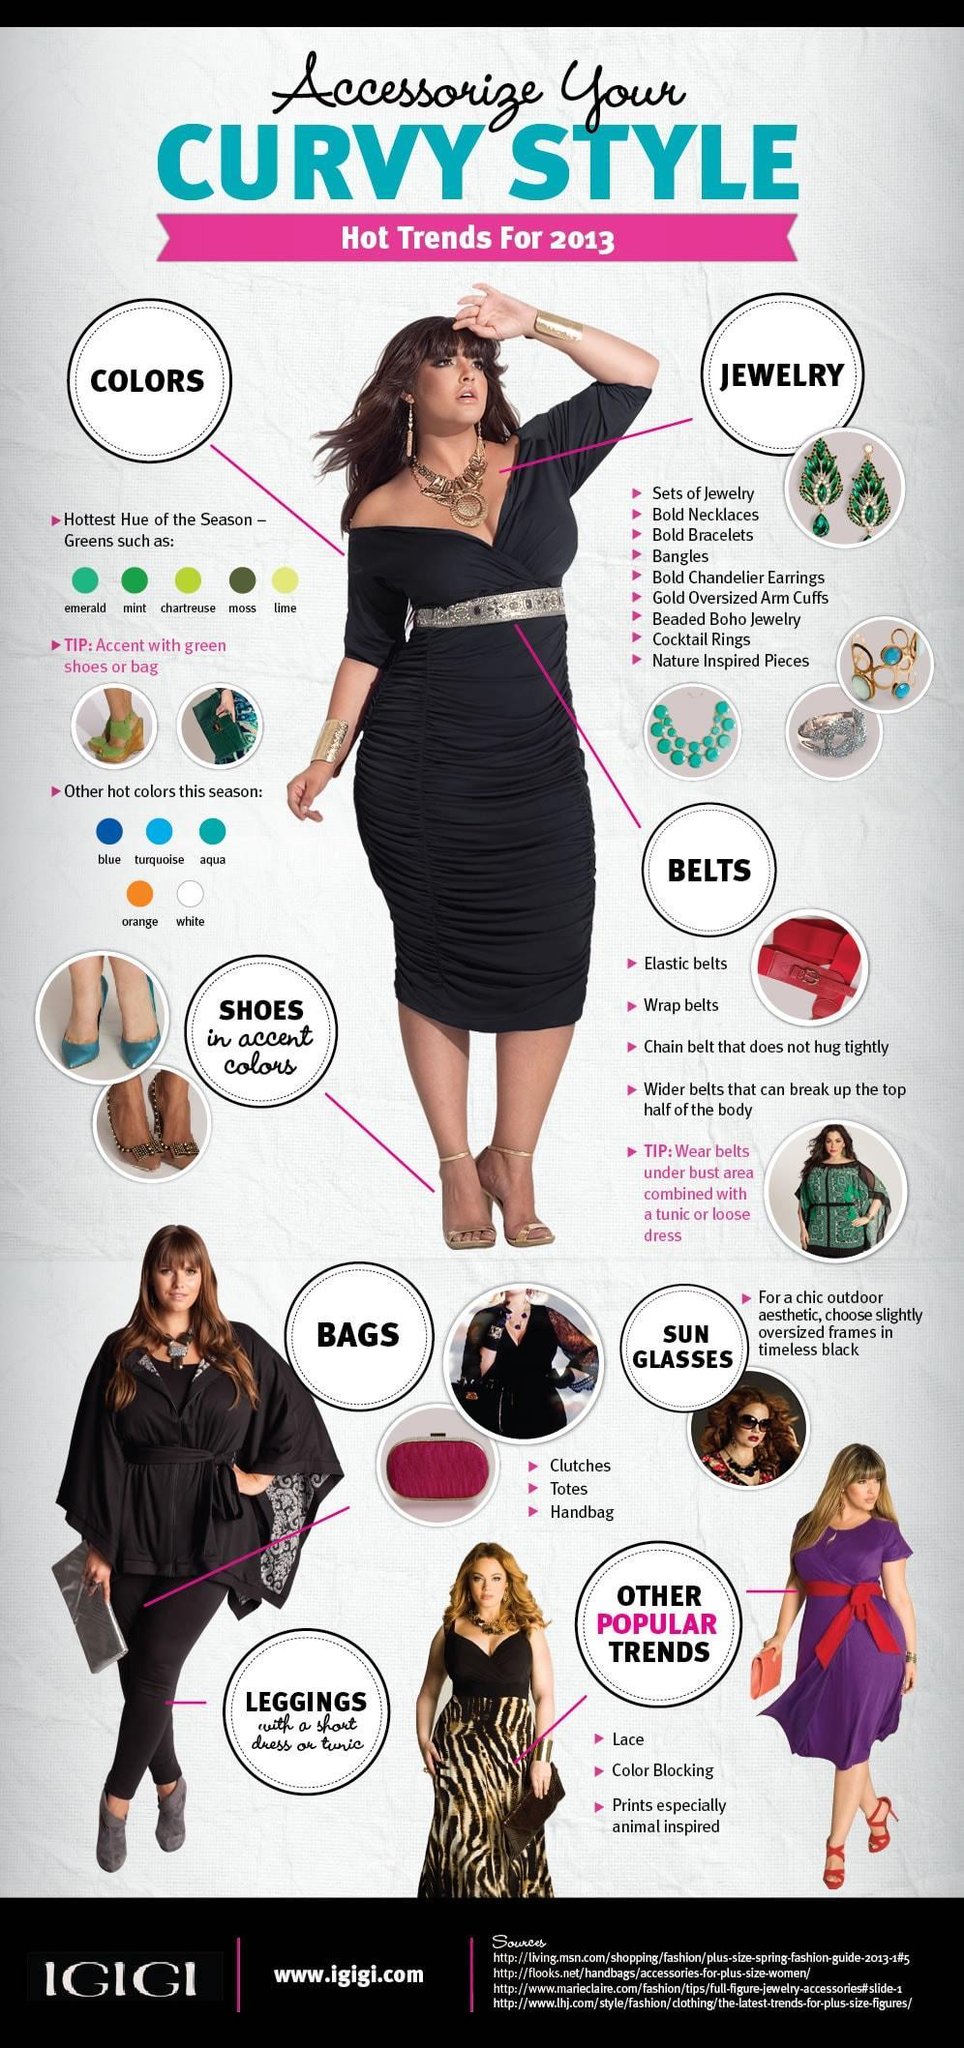How many types of belts are mentioned in this infographic?
Answer the question with a short phrase. 4 How many types of jewelry mentioned in this infographic? 9 How many shades of green colors are mentioned in this infographic? 5 How many hot colors of the season mentioned in this infographic? 5 How many types of bags mentioned in this infographic? 3 